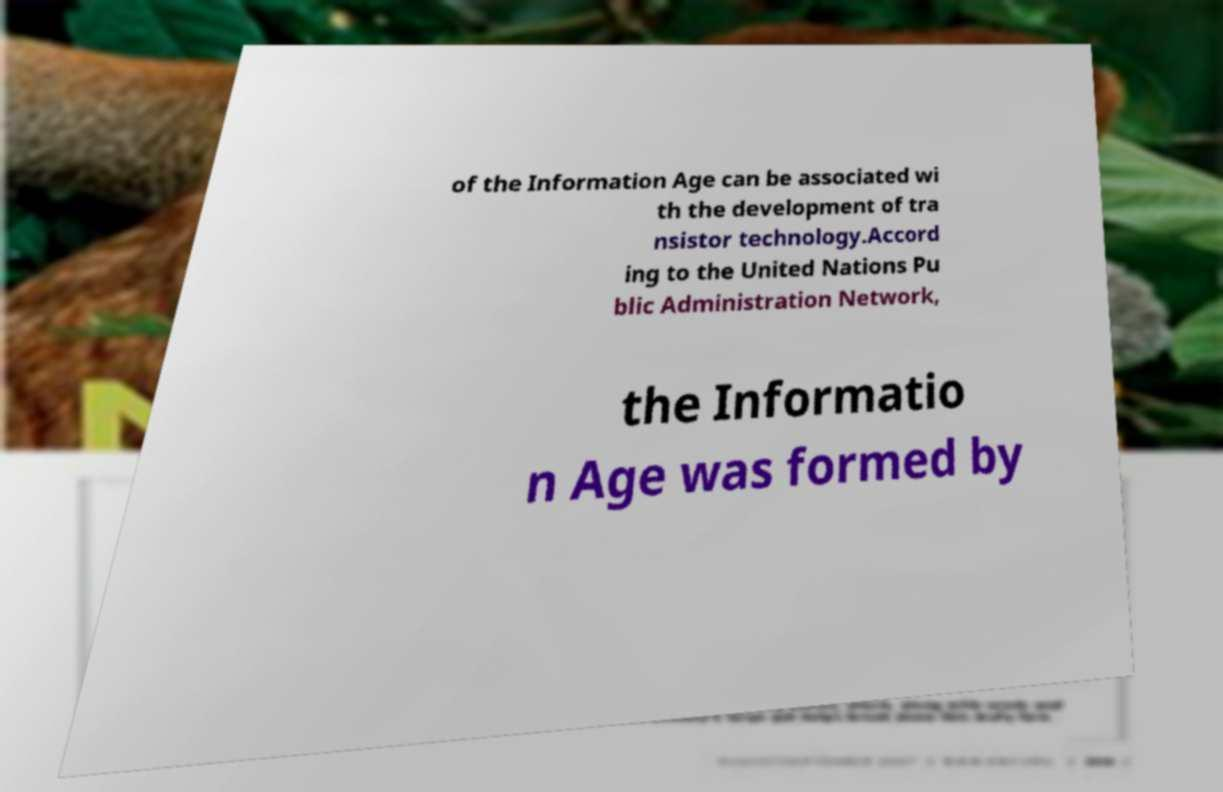Could you extract and type out the text from this image? of the Information Age can be associated wi th the development of tra nsistor technology.Accord ing to the United Nations Pu blic Administration Network, the Informatio n Age was formed by 